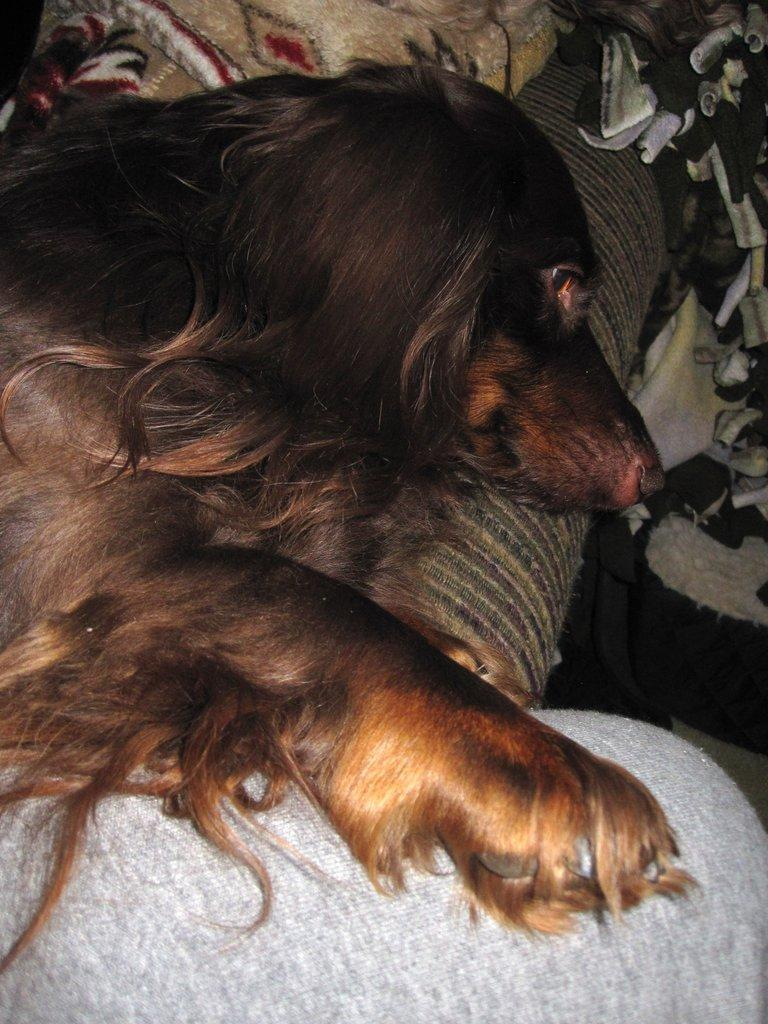What is the dog doing in the image? The dog is lying on a sofa. What else can be seen in the background of the image? There are clothes visible in the background. Can you describe any part of a person in the image? A person's leg is visible in the image. What time does the clock show in the image? There is no clock present in the image. How many men are visible in the image? There is no mention of men in the image, only a dog and a person's leg. Can you hear thunder in the image? There is no mention of thunder or any sound in the image, only visual details. 